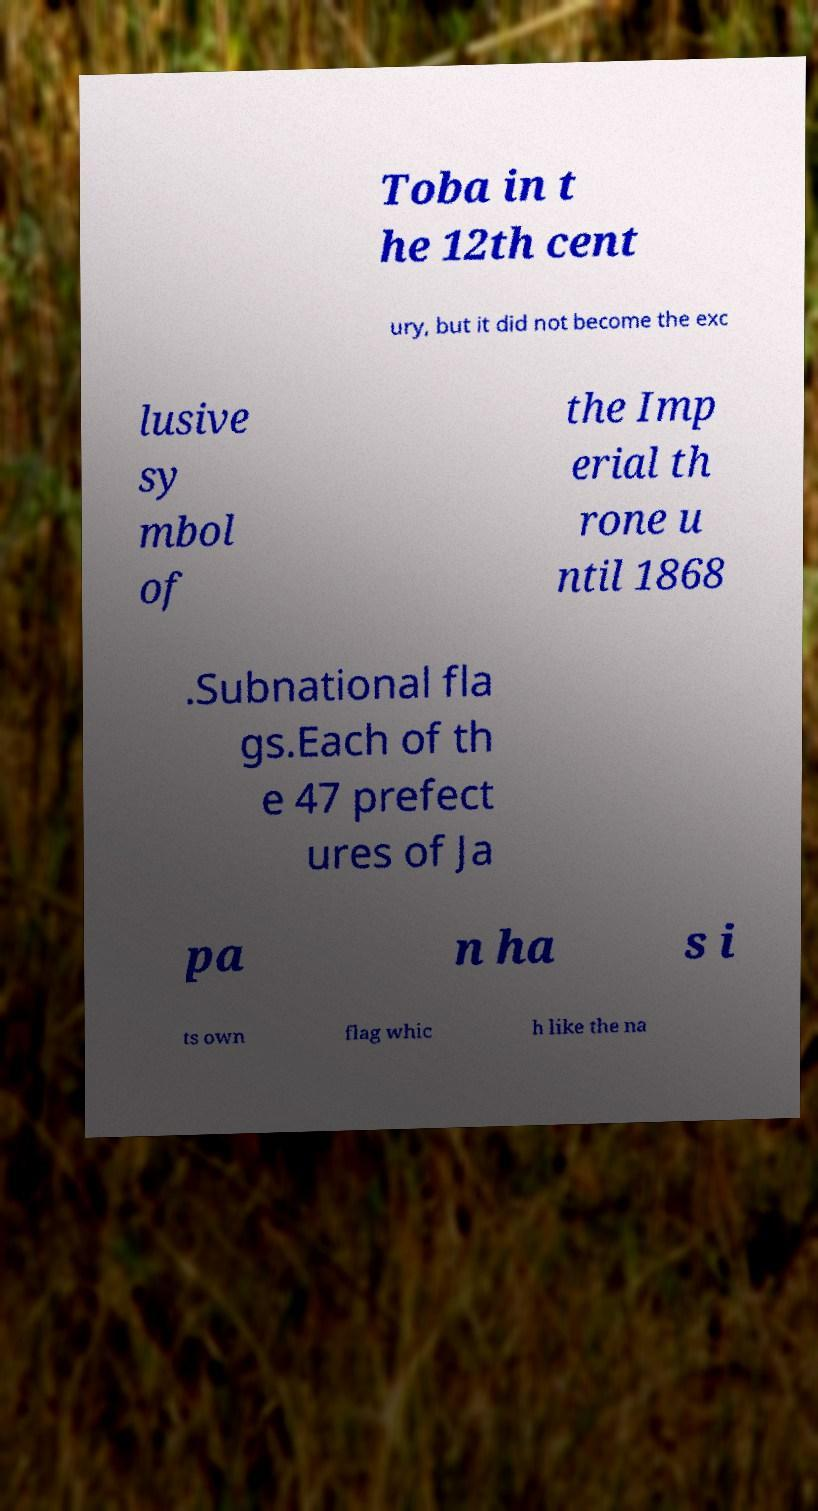Please read and relay the text visible in this image. What does it say? Toba in t he 12th cent ury, but it did not become the exc lusive sy mbol of the Imp erial th rone u ntil 1868 .Subnational fla gs.Each of th e 47 prefect ures of Ja pa n ha s i ts own flag whic h like the na 